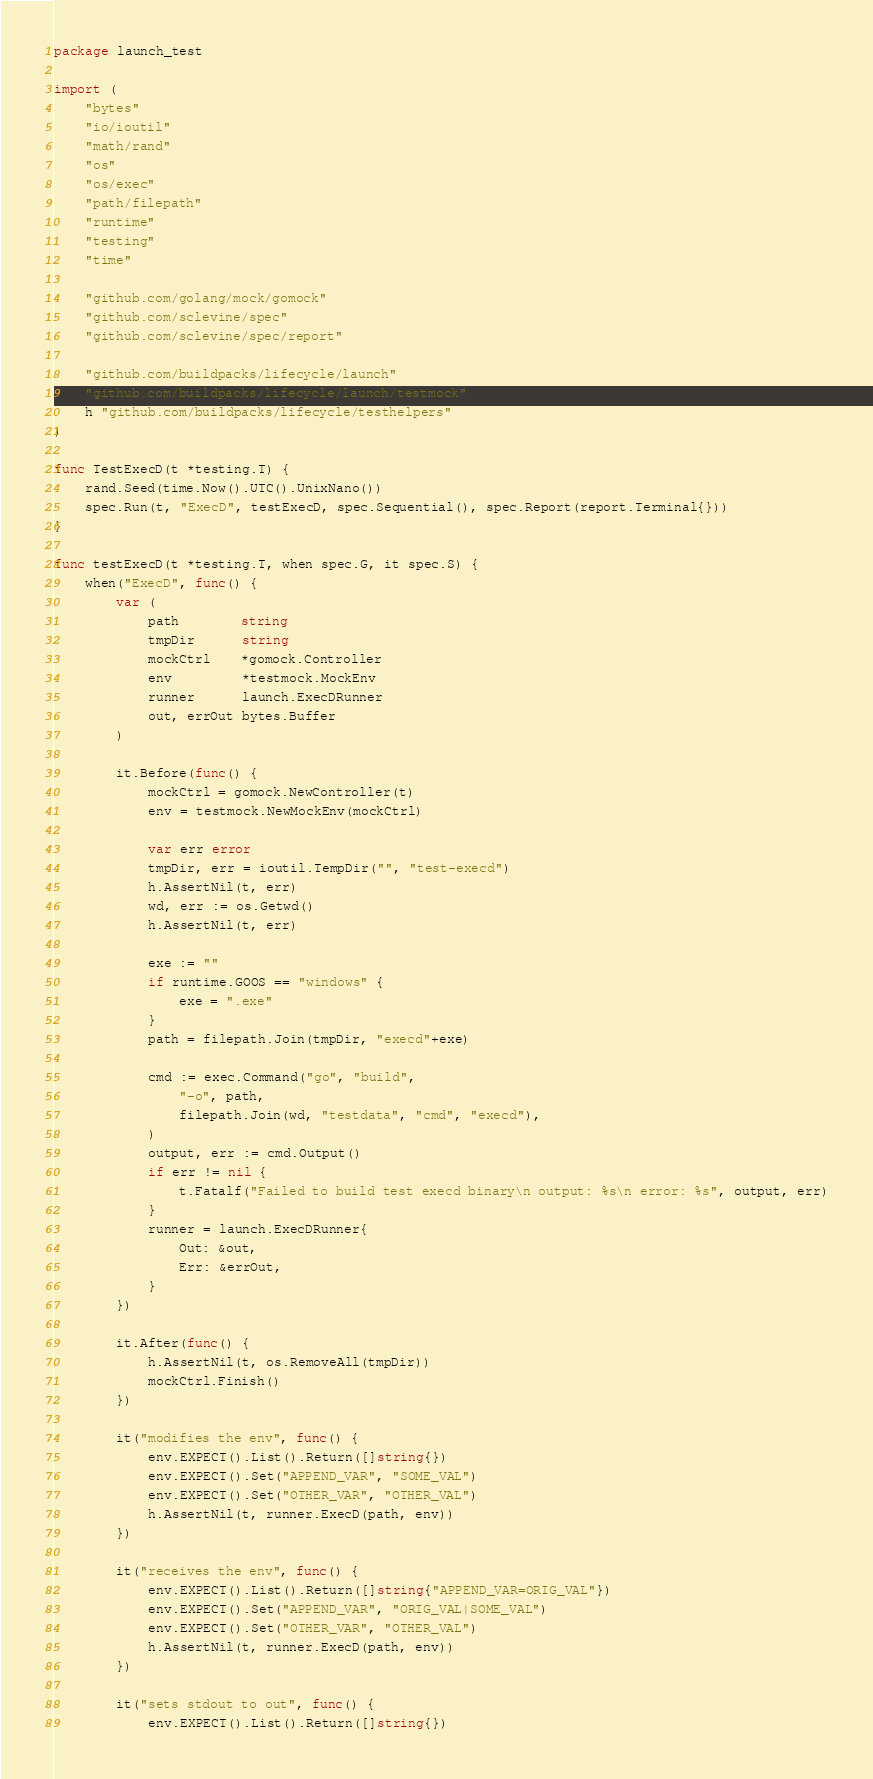Convert code to text. <code><loc_0><loc_0><loc_500><loc_500><_Go_>package launch_test

import (
	"bytes"
	"io/ioutil"
	"math/rand"
	"os"
	"os/exec"
	"path/filepath"
	"runtime"
	"testing"
	"time"

	"github.com/golang/mock/gomock"
	"github.com/sclevine/spec"
	"github.com/sclevine/spec/report"

	"github.com/buildpacks/lifecycle/launch"
	"github.com/buildpacks/lifecycle/launch/testmock"
	h "github.com/buildpacks/lifecycle/testhelpers"
)

func TestExecD(t *testing.T) {
	rand.Seed(time.Now().UTC().UnixNano())
	spec.Run(t, "ExecD", testExecD, spec.Sequential(), spec.Report(report.Terminal{}))
}

func testExecD(t *testing.T, when spec.G, it spec.S) {
	when("ExecD", func() {
		var (
			path        string
			tmpDir      string
			mockCtrl    *gomock.Controller
			env         *testmock.MockEnv
			runner      launch.ExecDRunner
			out, errOut bytes.Buffer
		)

		it.Before(func() {
			mockCtrl = gomock.NewController(t)
			env = testmock.NewMockEnv(mockCtrl)

			var err error
			tmpDir, err = ioutil.TempDir("", "test-execd")
			h.AssertNil(t, err)
			wd, err := os.Getwd()
			h.AssertNil(t, err)

			exe := ""
			if runtime.GOOS == "windows" {
				exe = ".exe"
			}
			path = filepath.Join(tmpDir, "execd"+exe)

			cmd := exec.Command("go", "build",
				"-o", path,
				filepath.Join(wd, "testdata", "cmd", "execd"),
			)
			output, err := cmd.Output()
			if err != nil {
				t.Fatalf("Failed to build test execd binary\n output: %s\n error: %s", output, err)
			}
			runner = launch.ExecDRunner{
				Out: &out,
				Err: &errOut,
			}
		})

		it.After(func() {
			h.AssertNil(t, os.RemoveAll(tmpDir))
			mockCtrl.Finish()
		})

		it("modifies the env", func() {
			env.EXPECT().List().Return([]string{})
			env.EXPECT().Set("APPEND_VAR", "SOME_VAL")
			env.EXPECT().Set("OTHER_VAR", "OTHER_VAL")
			h.AssertNil(t, runner.ExecD(path, env))
		})

		it("receives the env", func() {
			env.EXPECT().List().Return([]string{"APPEND_VAR=ORIG_VAL"})
			env.EXPECT().Set("APPEND_VAR", "ORIG_VAL|SOME_VAL")
			env.EXPECT().Set("OTHER_VAR", "OTHER_VAL")
			h.AssertNil(t, runner.ExecD(path, env))
		})

		it("sets stdout to out", func() {
			env.EXPECT().List().Return([]string{})</code> 